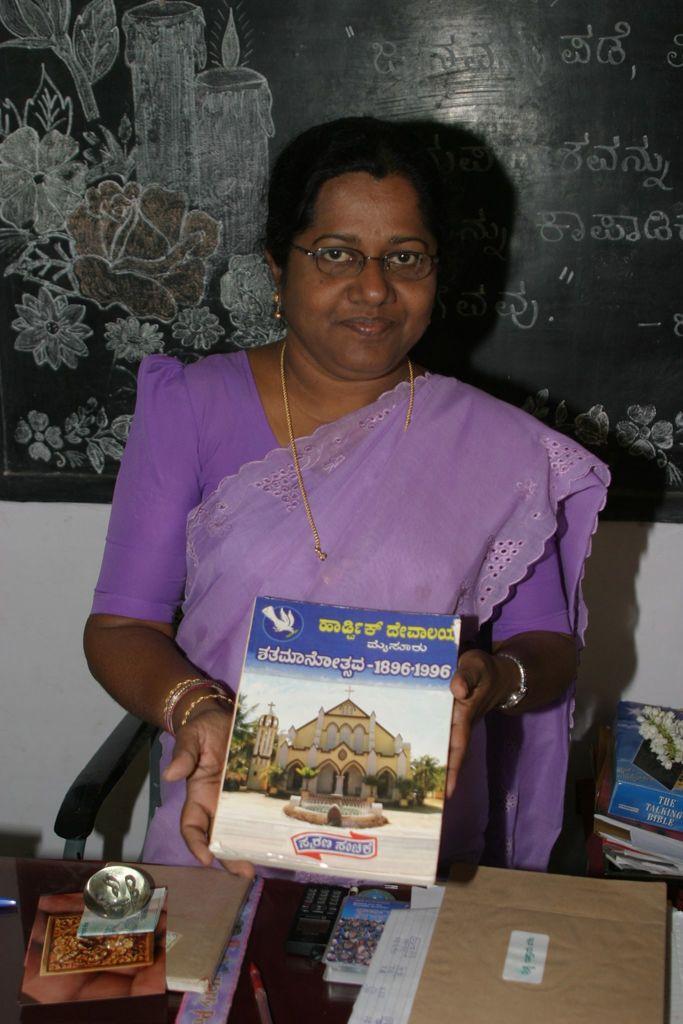Can you describe this image briefly? In this image I can see the person standing and wearing the purple color dress and holding the book. In-front of the person I can see the table. On the table I can see papers, pen and mobile. To the right there are many books. In the background I can see the blackboard to the wall. 